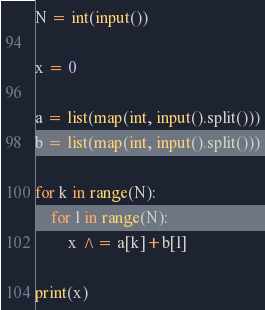Convert code to text. <code><loc_0><loc_0><loc_500><loc_500><_Python_>N = int(input())

x = 0

a = list(map(int, input().split()))
b = list(map(int, input().split()))

for k in range(N):
    for l in range(N):
        x ^= a[k]+b[l]

print(x)</code> 